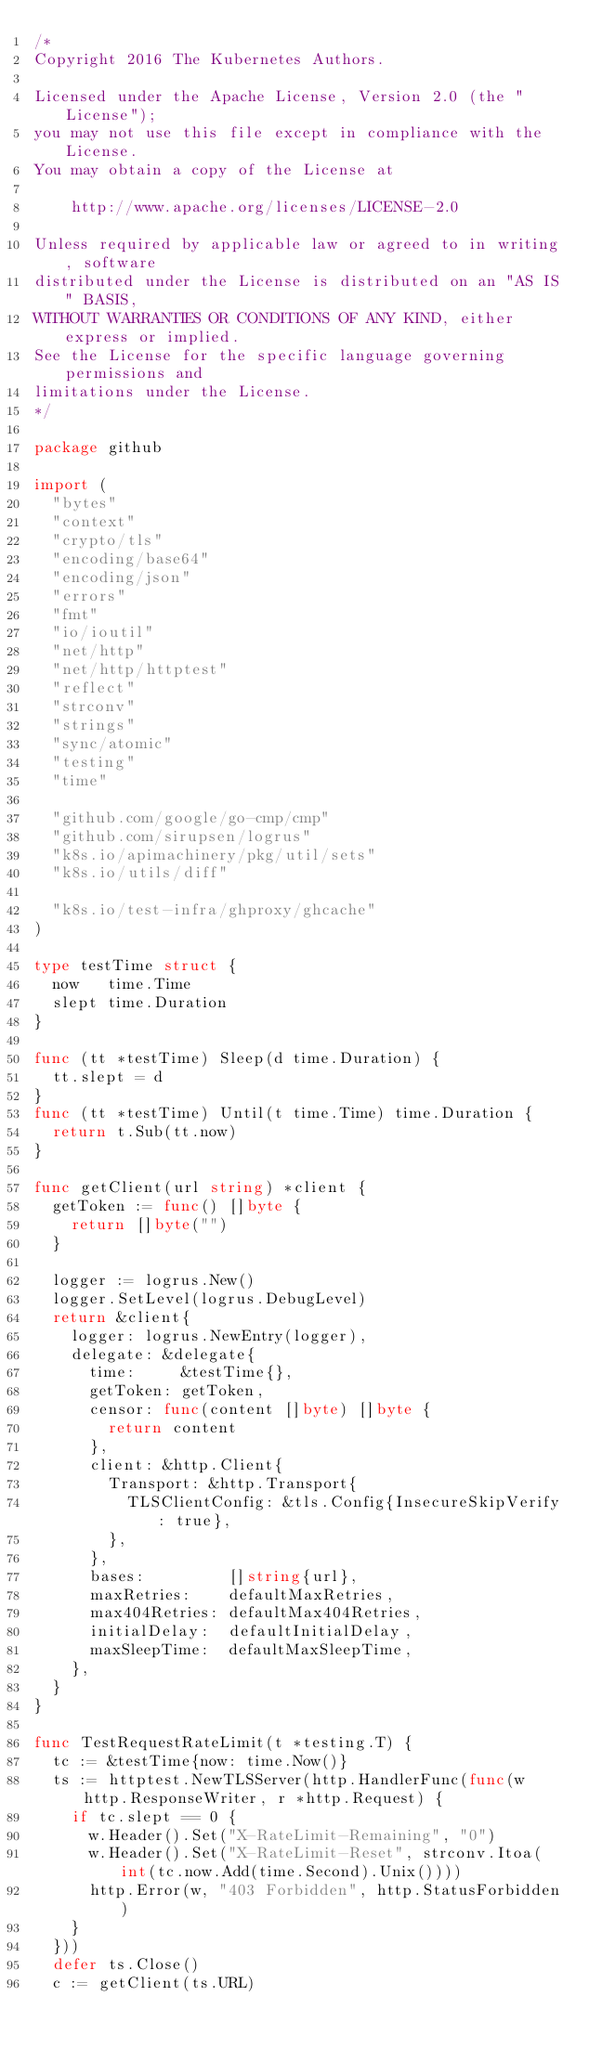<code> <loc_0><loc_0><loc_500><loc_500><_Go_>/*
Copyright 2016 The Kubernetes Authors.

Licensed under the Apache License, Version 2.0 (the "License");
you may not use this file except in compliance with the License.
You may obtain a copy of the License at

    http://www.apache.org/licenses/LICENSE-2.0

Unless required by applicable law or agreed to in writing, software
distributed under the License is distributed on an "AS IS" BASIS,
WITHOUT WARRANTIES OR CONDITIONS OF ANY KIND, either express or implied.
See the License for the specific language governing permissions and
limitations under the License.
*/

package github

import (
	"bytes"
	"context"
	"crypto/tls"
	"encoding/base64"
	"encoding/json"
	"errors"
	"fmt"
	"io/ioutil"
	"net/http"
	"net/http/httptest"
	"reflect"
	"strconv"
	"strings"
	"sync/atomic"
	"testing"
	"time"

	"github.com/google/go-cmp/cmp"
	"github.com/sirupsen/logrus"
	"k8s.io/apimachinery/pkg/util/sets"
	"k8s.io/utils/diff"

	"k8s.io/test-infra/ghproxy/ghcache"
)

type testTime struct {
	now   time.Time
	slept time.Duration
}

func (tt *testTime) Sleep(d time.Duration) {
	tt.slept = d
}
func (tt *testTime) Until(t time.Time) time.Duration {
	return t.Sub(tt.now)
}

func getClient(url string) *client {
	getToken := func() []byte {
		return []byte("")
	}

	logger := logrus.New()
	logger.SetLevel(logrus.DebugLevel)
	return &client{
		logger: logrus.NewEntry(logger),
		delegate: &delegate{
			time:     &testTime{},
			getToken: getToken,
			censor: func(content []byte) []byte {
				return content
			},
			client: &http.Client{
				Transport: &http.Transport{
					TLSClientConfig: &tls.Config{InsecureSkipVerify: true},
				},
			},
			bases:         []string{url},
			maxRetries:    defaultMaxRetries,
			max404Retries: defaultMax404Retries,
			initialDelay:  defaultInitialDelay,
			maxSleepTime:  defaultMaxSleepTime,
		},
	}
}

func TestRequestRateLimit(t *testing.T) {
	tc := &testTime{now: time.Now()}
	ts := httptest.NewTLSServer(http.HandlerFunc(func(w http.ResponseWriter, r *http.Request) {
		if tc.slept == 0 {
			w.Header().Set("X-RateLimit-Remaining", "0")
			w.Header().Set("X-RateLimit-Reset", strconv.Itoa(int(tc.now.Add(time.Second).Unix())))
			http.Error(w, "403 Forbidden", http.StatusForbidden)
		}
	}))
	defer ts.Close()
	c := getClient(ts.URL)</code> 